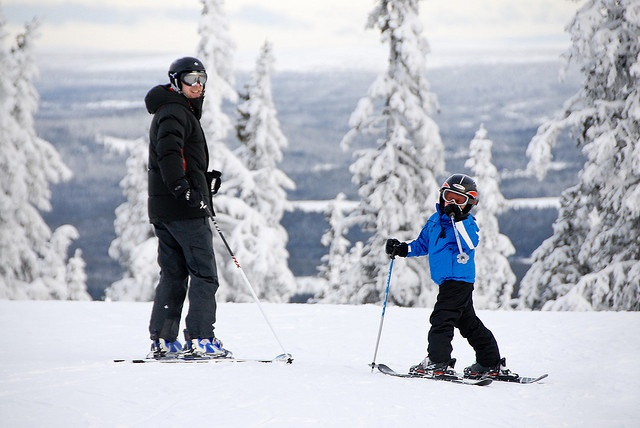Describe the objects in this image and their specific colors. I can see people in lightgray, black, gray, and darkgray tones, people in lightgray, black, and blue tones, and skis in lightgray, black, darkgray, and gray tones in this image. 